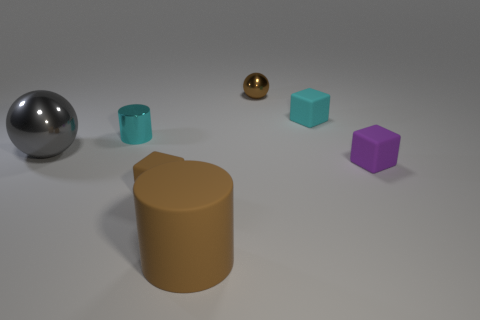Add 1 small rubber blocks. How many objects exist? 8 Subtract all balls. How many objects are left? 5 Add 2 large brown cylinders. How many large brown cylinders exist? 3 Subtract 0 gray cylinders. How many objects are left? 7 Subtract all tiny rubber objects. Subtract all brown balls. How many objects are left? 3 Add 5 cyan shiny cylinders. How many cyan shiny cylinders are left? 6 